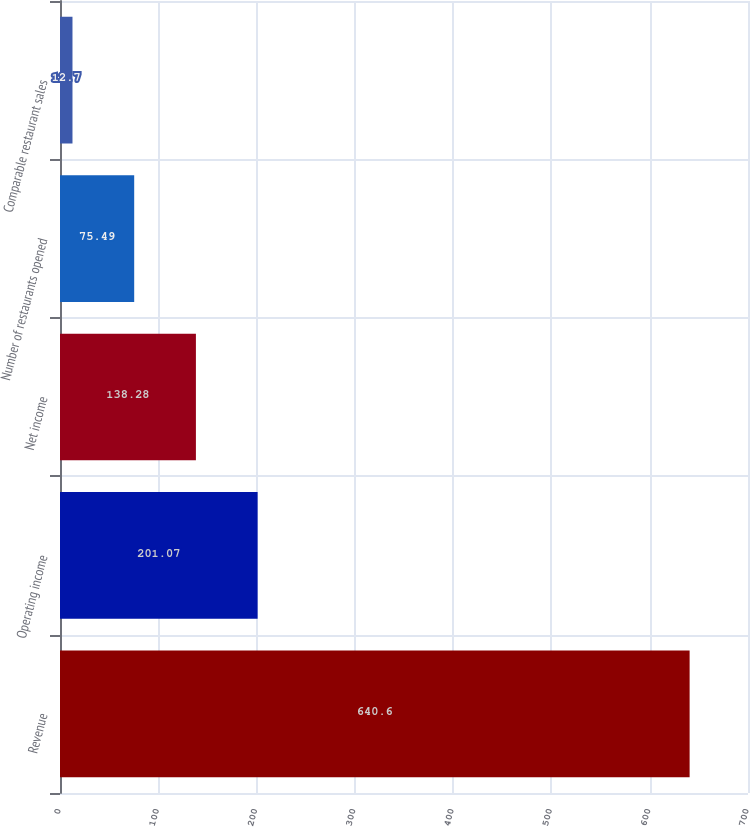<chart> <loc_0><loc_0><loc_500><loc_500><bar_chart><fcel>Revenue<fcel>Operating income<fcel>Net income<fcel>Number of restaurants opened<fcel>Comparable restaurant sales<nl><fcel>640.6<fcel>201.07<fcel>138.28<fcel>75.49<fcel>12.7<nl></chart> 